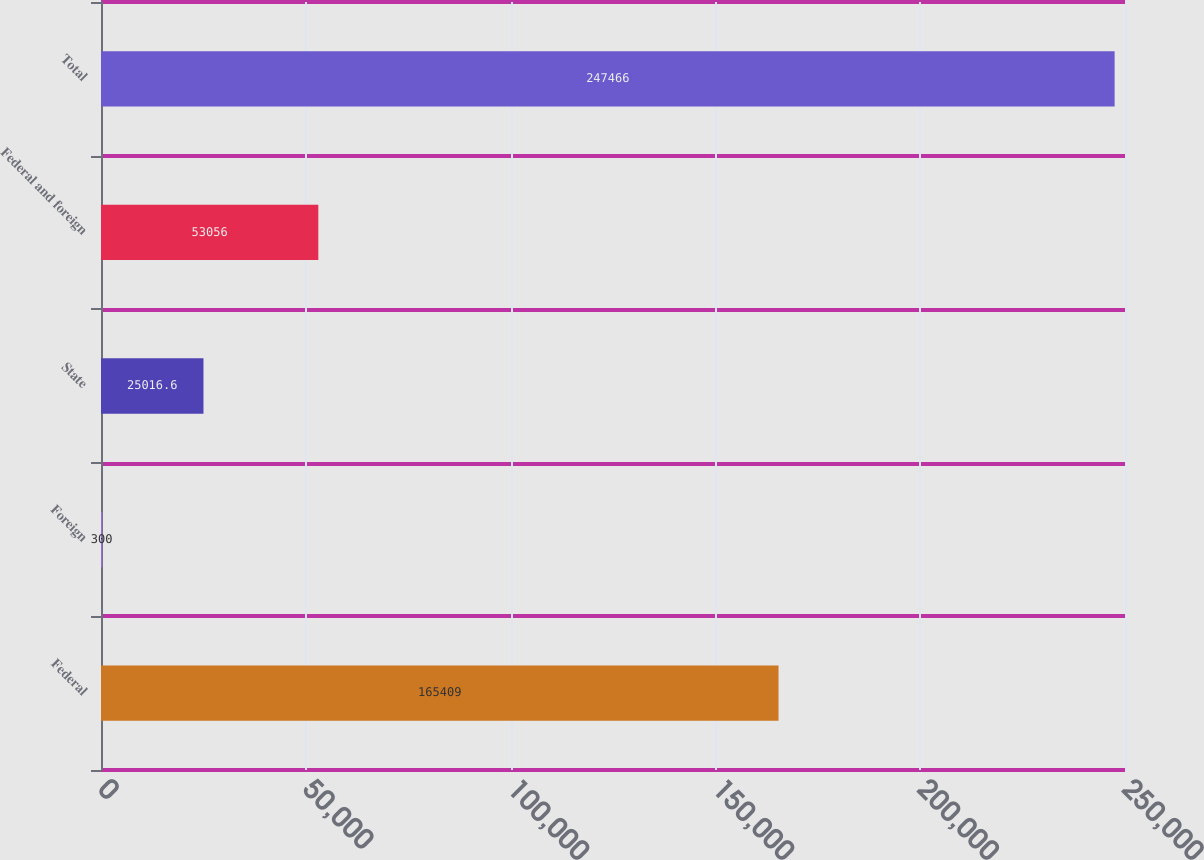Convert chart to OTSL. <chart><loc_0><loc_0><loc_500><loc_500><bar_chart><fcel>Federal<fcel>Foreign<fcel>State<fcel>Federal and foreign<fcel>Total<nl><fcel>165409<fcel>300<fcel>25016.6<fcel>53056<fcel>247466<nl></chart> 